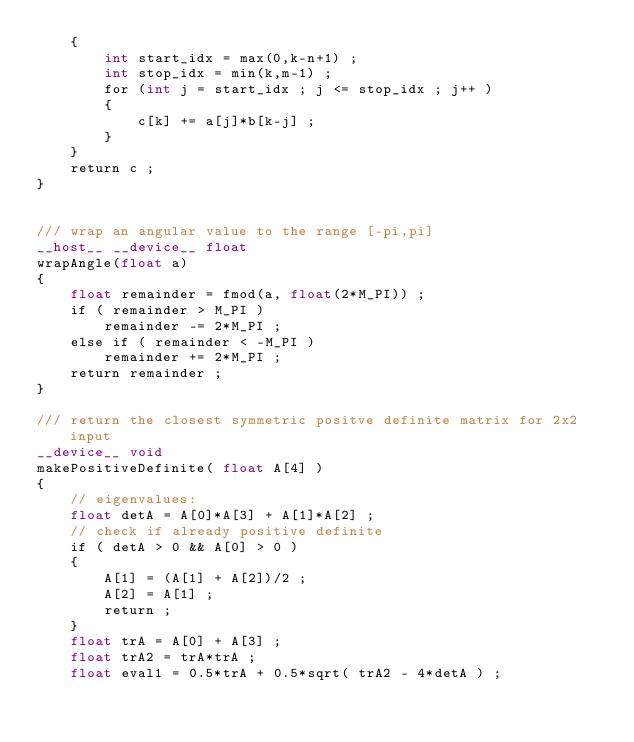<code> <loc_0><loc_0><loc_500><loc_500><_Cuda_>    {
        int start_idx = max(0,k-n+1) ;
        int stop_idx = min(k,m-1) ;
        for (int j = start_idx ; j <= stop_idx ; j++ )
        {
            c[k] += a[j]*b[k-j] ;
        }
    }
    return c ;
}


/// wrap an angular value to the range [-pi,pi]
__host__ __device__ float
wrapAngle(float a)
{
    float remainder = fmod(a, float(2*M_PI)) ;
    if ( remainder > M_PI )
        remainder -= 2*M_PI ;
    else if ( remainder < -M_PI )
        remainder += 2*M_PI ;
    return remainder ;
}

/// return the closest symmetric positve definite matrix for 2x2 input
__device__ void
makePositiveDefinite( float A[4] )
{
    // eigenvalues:
    float detA = A[0]*A[3] + A[1]*A[2] ;
    // check if already positive definite
    if ( detA > 0 && A[0] > 0 )
    {
        A[1] = (A[1] + A[2])/2 ;
        A[2] = A[1] ;
        return ;
    }
    float trA = A[0] + A[3] ;
    float trA2 = trA*trA ;
    float eval1 = 0.5*trA + 0.5*sqrt( trA2 - 4*detA ) ;</code> 